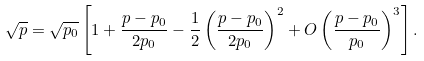<formula> <loc_0><loc_0><loc_500><loc_500>\sqrt { p } = \sqrt { p _ { 0 } } \left [ 1 + \frac { p - p _ { 0 } } { 2 p _ { 0 } } - \frac { 1 } { 2 } \left ( \frac { p - p _ { 0 } } { 2 p _ { 0 } } \right ) ^ { 2 } + O \left ( \frac { p - p _ { 0 } } { p _ { 0 } } \right ) ^ { 3 } \right ] .</formula> 